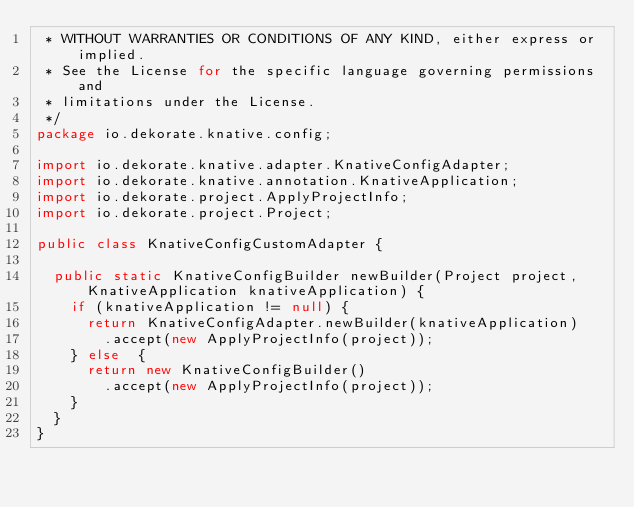Convert code to text. <code><loc_0><loc_0><loc_500><loc_500><_Java_> * WITHOUT WARRANTIES OR CONDITIONS OF ANY KIND, either express or implied.
 * See the License for the specific language governing permissions and
 * limitations under the License.
 */
package io.dekorate.knative.config;

import io.dekorate.knative.adapter.KnativeConfigAdapter;
import io.dekorate.knative.annotation.KnativeApplication;
import io.dekorate.project.ApplyProjectInfo;
import io.dekorate.project.Project;

public class KnativeConfigCustomAdapter {

  public static KnativeConfigBuilder newBuilder(Project project, KnativeApplication knativeApplication) {
    if (knativeApplication != null) {
      return KnativeConfigAdapter.newBuilder(knativeApplication)
        .accept(new ApplyProjectInfo(project));
    } else  {
      return new KnativeConfigBuilder()
        .accept(new ApplyProjectInfo(project));
    }
  }
}
</code> 